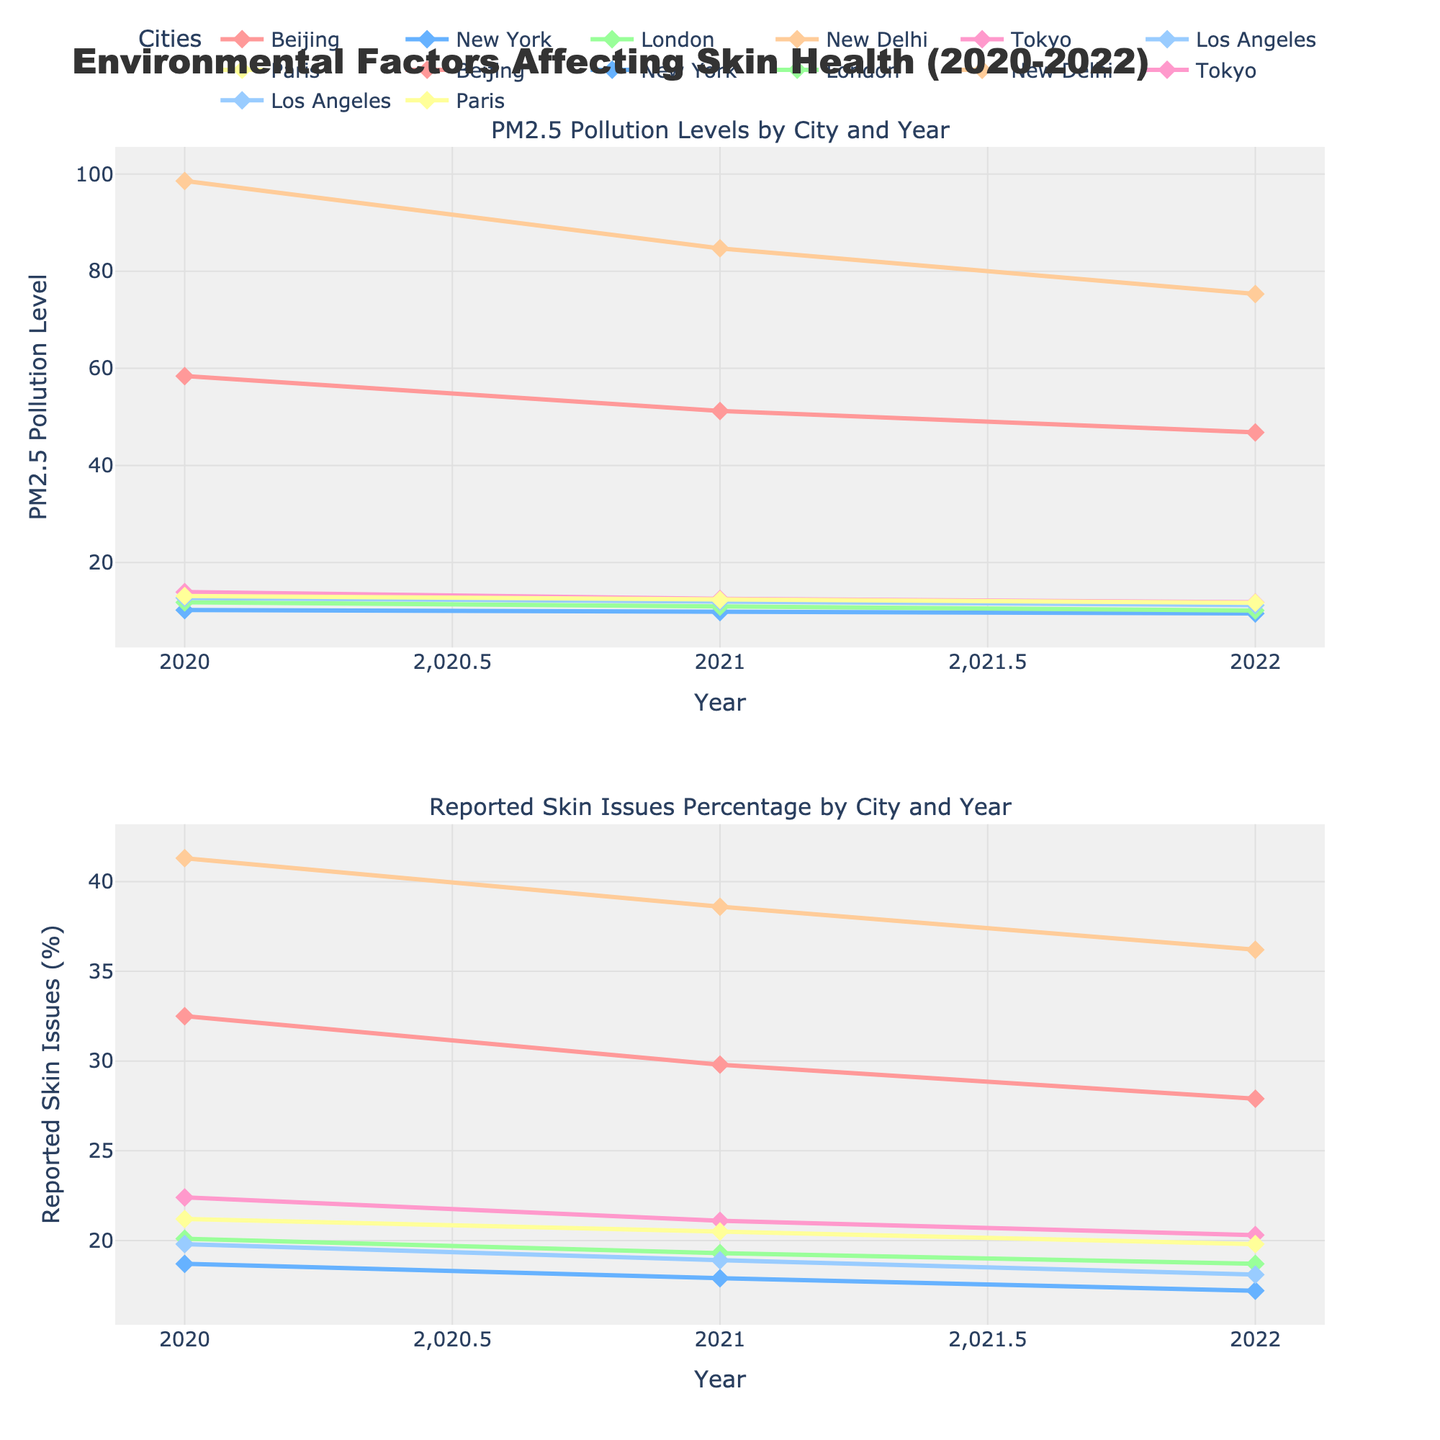What does the figure's title indicate? The figure's title is "Environmental Factors Affecting Skin Health (2020-2022)", which indicates that the plots show data pertaining to how environmental factors, specifically PM2.5 pollution levels, impact skin health over the years from 2020 to 2022.
Answer: Environmental Factors Affecting Skin Health (2020-2022) What are the two subplots about? The top subplot shows "PM2.5 Pollution Levels by City and Year" and the bottom subplot shows "Reported Skin Issues Percentage by City and Year".
Answer: PM2.5 Pollution Levels by City and Year; Reported Skin Issues Percentage by City and Year Which city had the highest PM2.5 pollution level in 2022? In the upper subplot, looking at the year axis and finding the highest point on the PM2.5 Pollution Level axis, New Delhi had the highest pollution level at 75.3 in 2022.
Answer: New Delhi How does the trend in reported skin issues in Beijing from 2020 to 2022 compare to the trend in PM2.5 pollution levels? In the figure, the upper subplot shows that pollution levels in Beijing decreased from 58.4 in 2020 to 51.2 in 2021 and 46.8 in 2022. In the lower subplot, reported skin issues in Beijing follow a similar decreasing trend from 32.5% in 2020 to 29.8% in 2021 and 27.9% in 2022.
Answer: Both trends are decreasing What's the difference in reported skin issues percentage between New Delhi and Tokyo in 2020? In the lower subplot, New Delhi had 41.3% and Tokyo had 22.4% reported skin issues in 2020. The difference is calculated as 41.3 - 22.4 = 18.9%.
Answer: 18.9% Which city shows a consistent increase in reported skin issues from 2020 to 2022? In the lower subplot, no city shows a consistent increase in skin issues from 2020 to 2022; most cities either show decreases or fluctuations.
Answer: None Is there a visible correlation between PM2.5 pollution levels and reported skin issues in New York from 2020 to 2022? In the figure, both subplots for New York show a decreasing trend in PM2.5 pollution levels from 10.2 in 2020 to 9.5 in 2022 and a similar decreasing trend in reported skin issues from 18.7% in 2020 to 17.2% in 2022, indicating a potential correlation.
Answer: Yes Which year had the highest reported skin issues percentage across all cities, and what was the percentage? In the lower subplot, the highest reported skin issues across all cities appear in the year 2020 in New Delhi with a percentage of 41.3%.
Answer: 2020; 41.3% Compare the change in pollution levels and skin issues for Paris from 2020 to 2022. In the figure, the upper subplot shows that Paris had a decrease in pollution levels from 13.1 in 2020 to 11.7 in 2022. In the lower subplot, reported skin issues in Paris dropped slightly from 21.2% to 19.8% over the same period.
Answer: Both decreased 